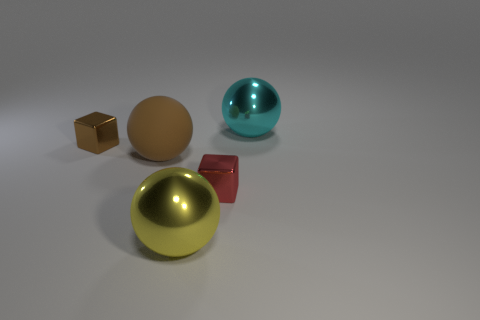What material is the large sphere that is right of the cube in front of the small shiny block that is to the left of the yellow metal object made of? The large sphere to the right of the cube and in front of the small shiny block, which is left of the yellow metal object, appears to be made of a smooth, reflective material, consistent with metallic properties, possibly a polished metal like chrome or stainless steel. 